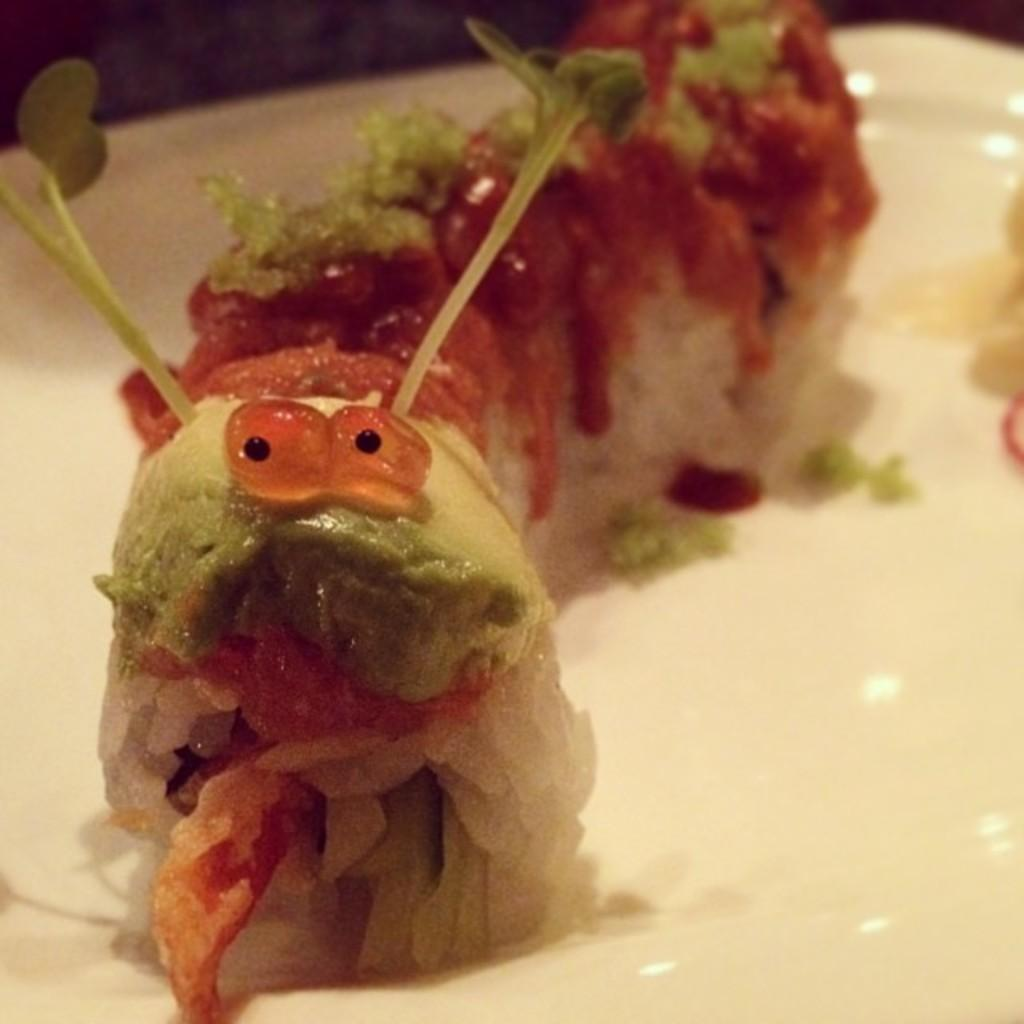What is there is a cooked food item in the image, what is it served on? The food item is served on a plate. Can you describe the cooked food item in the image? Unfortunately, the specific type of cooked food item is not mentioned in the provided facts. What is the primary element used for serving the food item in the image? The primary element used for serving the food item is a plate. What type of fruit is being used as a body for the cooked food item in the image? There is no fruit or body present in the image; it only features a cooked food item served on a plate. 